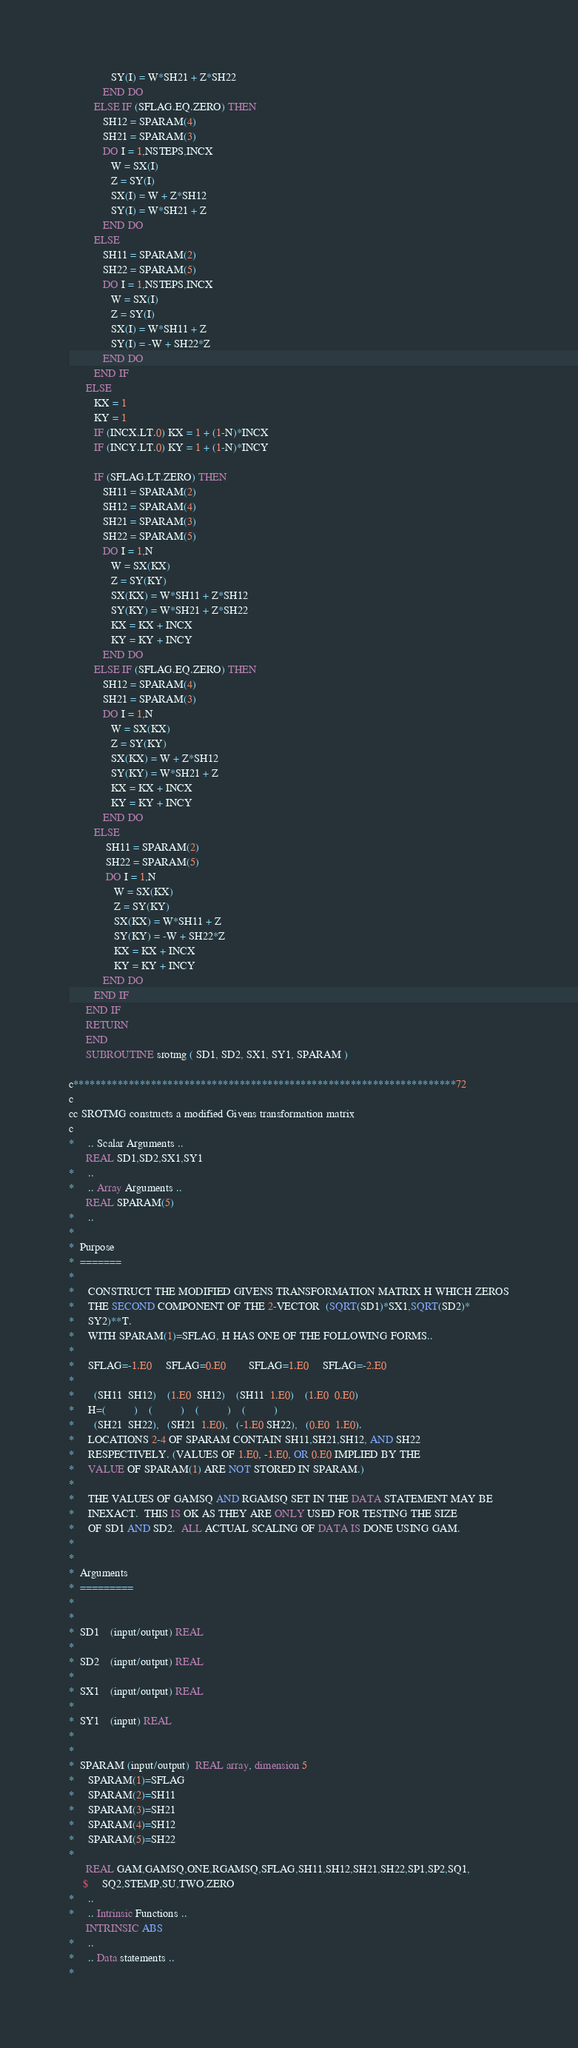Convert code to text. <code><loc_0><loc_0><loc_500><loc_500><_FORTRAN_>               SY(I) = W*SH21 + Z*SH22
            END DO
         ELSE IF (SFLAG.EQ.ZERO) THEN
            SH12 = SPARAM(4)
            SH21 = SPARAM(3)
            DO I = 1,NSTEPS,INCX
               W = SX(I)
               Z = SY(I)
               SX(I) = W + Z*SH12
               SY(I) = W*SH21 + Z
            END DO
         ELSE
            SH11 = SPARAM(2)
            SH22 = SPARAM(5)
            DO I = 1,NSTEPS,INCX
               W = SX(I)
               Z = SY(I)
               SX(I) = W*SH11 + Z
               SY(I) = -W + SH22*Z
            END DO
         END IF
      ELSE
         KX = 1
         KY = 1
         IF (INCX.LT.0) KX = 1 + (1-N)*INCX
         IF (INCY.LT.0) KY = 1 + (1-N)*INCY

         IF (SFLAG.LT.ZERO) THEN
            SH11 = SPARAM(2)
            SH12 = SPARAM(4)
            SH21 = SPARAM(3)
            SH22 = SPARAM(5)
            DO I = 1,N
               W = SX(KX)
               Z = SY(KY)
               SX(KX) = W*SH11 + Z*SH12
               SY(KY) = W*SH21 + Z*SH22
               KX = KX + INCX
               KY = KY + INCY
            END DO
         ELSE IF (SFLAG.EQ.ZERO) THEN
            SH12 = SPARAM(4)
            SH21 = SPARAM(3)
            DO I = 1,N
               W = SX(KX)
               Z = SY(KY)
               SX(KX) = W + Z*SH12
               SY(KY) = W*SH21 + Z
               KX = KX + INCX
               KY = KY + INCY
            END DO
         ELSE
             SH11 = SPARAM(2)
             SH22 = SPARAM(5)
             DO I = 1,N
                W = SX(KX)
                Z = SY(KY)
                SX(KX) = W*SH11 + Z
                SY(KY) = -W + SH22*Z
                KX = KX + INCX
                KY = KY + INCY
            END DO
         END IF
      END IF
      RETURN
      END
      SUBROUTINE srotmg ( SD1, SD2, SX1, SY1, SPARAM )

c*********************************************************************72
c
cc SROTMG constructs a modified Givens transformation matrix
c
*     .. Scalar Arguments ..
      REAL SD1,SD2,SX1,SY1
*     ..
*     .. Array Arguments ..
      REAL SPARAM(5)
*     ..
*
*  Purpose
*  =======
*
*     CONSTRUCT THE MODIFIED GIVENS TRANSFORMATION MATRIX H WHICH ZEROS
*     THE SECOND COMPONENT OF THE 2-VECTOR  (SQRT(SD1)*SX1,SQRT(SD2)*
*     SY2)**T.
*     WITH SPARAM(1)=SFLAG, H HAS ONE OF THE FOLLOWING FORMS..
*
*     SFLAG=-1.E0     SFLAG=0.E0        SFLAG=1.E0     SFLAG=-2.E0
*
*       (SH11  SH12)    (1.E0  SH12)    (SH11  1.E0)    (1.E0  0.E0)
*     H=(          )    (          )    (          )    (          )
*       (SH21  SH22),   (SH21  1.E0),   (-1.E0 SH22),   (0.E0  1.E0).
*     LOCATIONS 2-4 OF SPARAM CONTAIN SH11,SH21,SH12, AND SH22
*     RESPECTIVELY. (VALUES OF 1.E0, -1.E0, OR 0.E0 IMPLIED BY THE
*     VALUE OF SPARAM(1) ARE NOT STORED IN SPARAM.)
*
*     THE VALUES OF GAMSQ AND RGAMSQ SET IN THE DATA STATEMENT MAY BE
*     INEXACT.  THIS IS OK AS THEY ARE ONLY USED FOR TESTING THE SIZE
*     OF SD1 AND SD2.  ALL ACTUAL SCALING OF DATA IS DONE USING GAM.
*
*
*  Arguments
*  =========
*
*
*  SD1    (input/output) REAL
*
*  SD2    (input/output) REAL
*
*  SX1    (input/output) REAL
*
*  SY1    (input) REAL
*
*
*  SPARAM (input/output)  REAL array, dimension 5
*     SPARAM(1)=SFLAG
*     SPARAM(2)=SH11
*     SPARAM(3)=SH21
*     SPARAM(4)=SH12
*     SPARAM(5)=SH22
*
      REAL GAM,GAMSQ,ONE,RGAMSQ,SFLAG,SH11,SH12,SH21,SH22,SP1,SP2,SQ1,
     $     SQ2,STEMP,SU,TWO,ZERO
*     ..
*     .. Intrinsic Functions ..
      INTRINSIC ABS
*     ..
*     .. Data statements ..
*</code> 